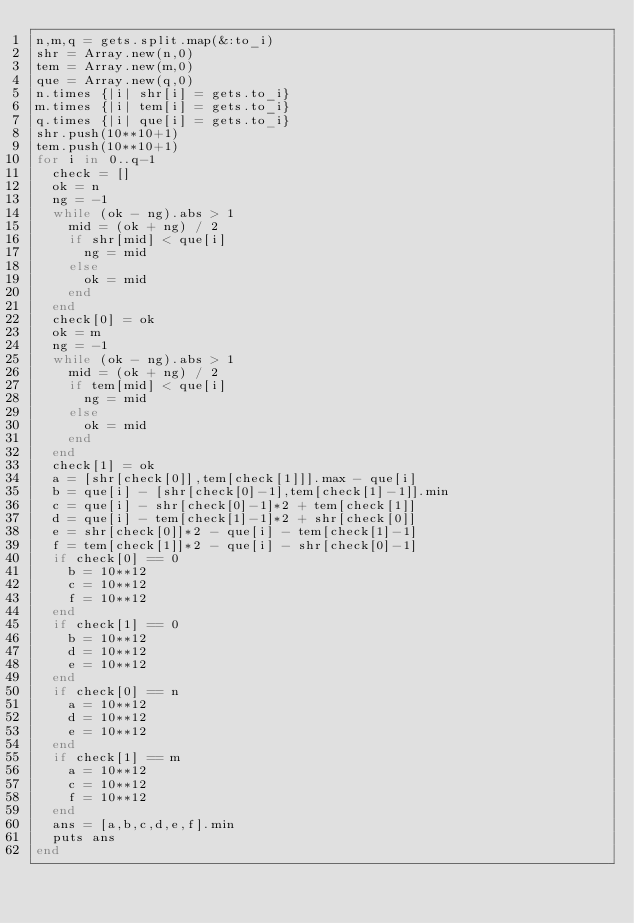<code> <loc_0><loc_0><loc_500><loc_500><_Ruby_>n,m,q = gets.split.map(&:to_i)
shr = Array.new(n,0)
tem = Array.new(m,0)
que = Array.new(q,0)
n.times {|i| shr[i] = gets.to_i}
m.times {|i| tem[i] = gets.to_i}
q.times {|i| que[i] = gets.to_i}
shr.push(10**10+1)
tem.push(10**10+1)
for i in 0..q-1
  check = []
  ok = n
  ng = -1
  while (ok - ng).abs > 1
    mid = (ok + ng) / 2
    if shr[mid] < que[i]
      ng = mid
    else
      ok = mid
    end
  end
  check[0] = ok
  ok = m
  ng = -1
  while (ok - ng).abs > 1
    mid = (ok + ng) / 2
    if tem[mid] < que[i]
      ng = mid
    else
      ok = mid
    end
  end
  check[1] = ok
  a = [shr[check[0]],tem[check[1]]].max - que[i]
  b = que[i] - [shr[check[0]-1],tem[check[1]-1]].min
  c = que[i] - shr[check[0]-1]*2 + tem[check[1]]
  d = que[i] - tem[check[1]-1]*2 + shr[check[0]]
  e = shr[check[0]]*2 - que[i] - tem[check[1]-1]
  f = tem[check[1]]*2 - que[i] - shr[check[0]-1]
  if check[0] == 0
    b = 10**12
    c = 10**12
    f = 10**12
  end
  if check[1] == 0
    b = 10**12
    d = 10**12
    e = 10**12
  end
  if check[0] == n
    a = 10**12
    d = 10**12
    e = 10**12
  end
  if check[1] == m
    a = 10**12
    c = 10**12
    f = 10**12
  end
  ans = [a,b,c,d,e,f].min
  puts ans
end
</code> 